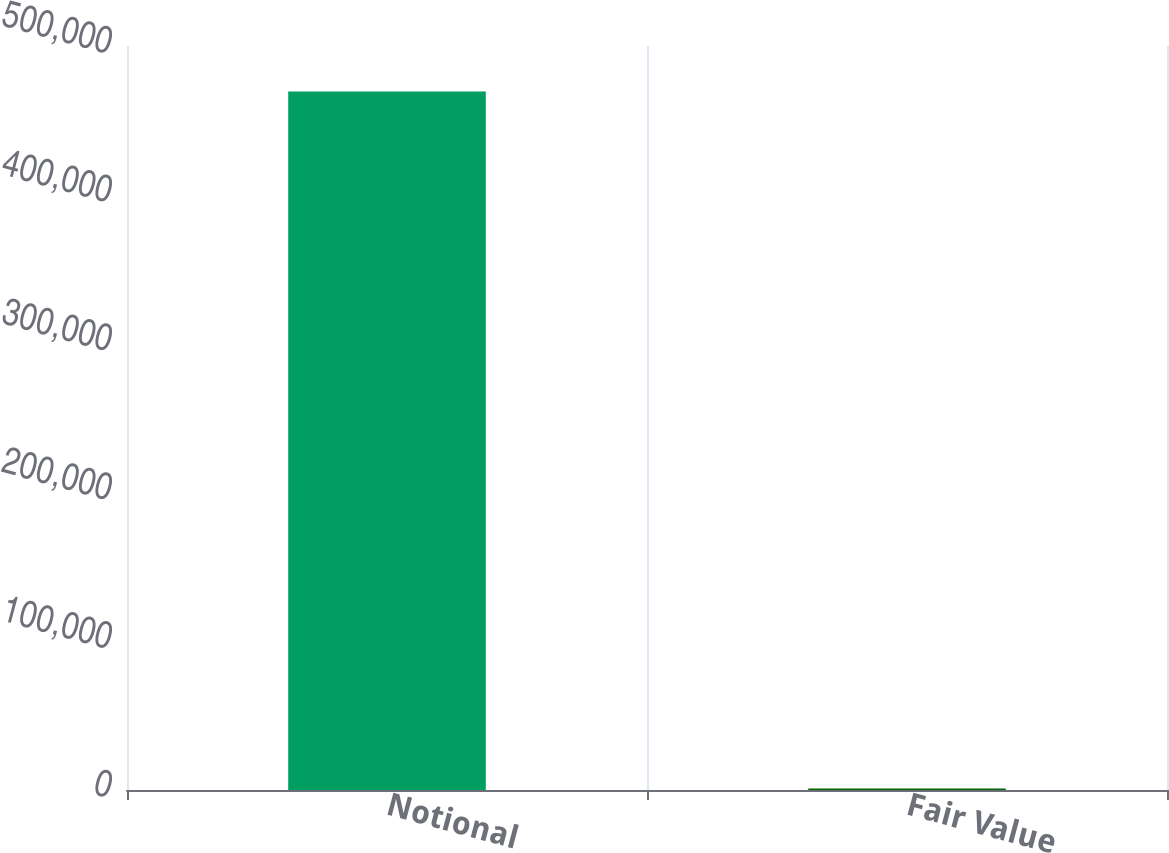Convert chart to OTSL. <chart><loc_0><loc_0><loc_500><loc_500><bar_chart><fcel>Notional<fcel>Fair Value<nl><fcel>469354<fcel>939<nl></chart> 